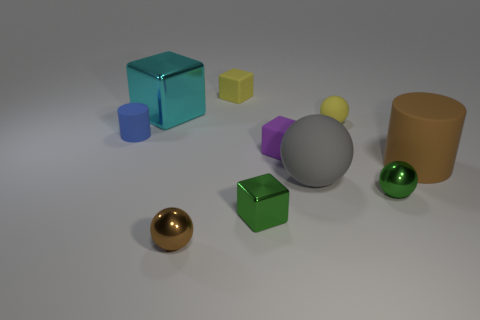Is there any other thing that is the same size as the gray matte ball?
Provide a succinct answer. Yes. What shape is the brown object right of the brown thing that is left of the yellow rubber cube?
Your response must be concise. Cylinder. How many objects are behind the big cyan metal object?
Your answer should be compact. 1. Is there a large cyan block that has the same material as the purple object?
Your response must be concise. No. There is a block that is the same size as the brown matte cylinder; what is it made of?
Give a very brief answer. Metal. How big is the matte object that is both to the left of the purple thing and right of the tiny blue rubber cylinder?
Provide a short and direct response. Small. What is the color of the rubber thing that is both left of the small metal cube and on the right side of the small brown object?
Keep it short and to the point. Yellow. Is the number of tiny objects that are to the left of the tiny brown object less than the number of tiny matte cubes that are behind the tiny purple block?
Provide a succinct answer. No. What number of small yellow matte objects are the same shape as the big gray thing?
Provide a short and direct response. 1. There is a blue cylinder that is the same material as the small purple block; what is its size?
Offer a terse response. Small. 